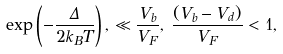Convert formula to latex. <formula><loc_0><loc_0><loc_500><loc_500>\exp \left ( - \frac { \Delta } { 2 k _ { B } T } \right ) , \, \ll \frac { V _ { b } } { V _ { F } } , \, \frac { ( V _ { b } - V _ { d } ) } { V _ { F } } < 1 ,</formula> 